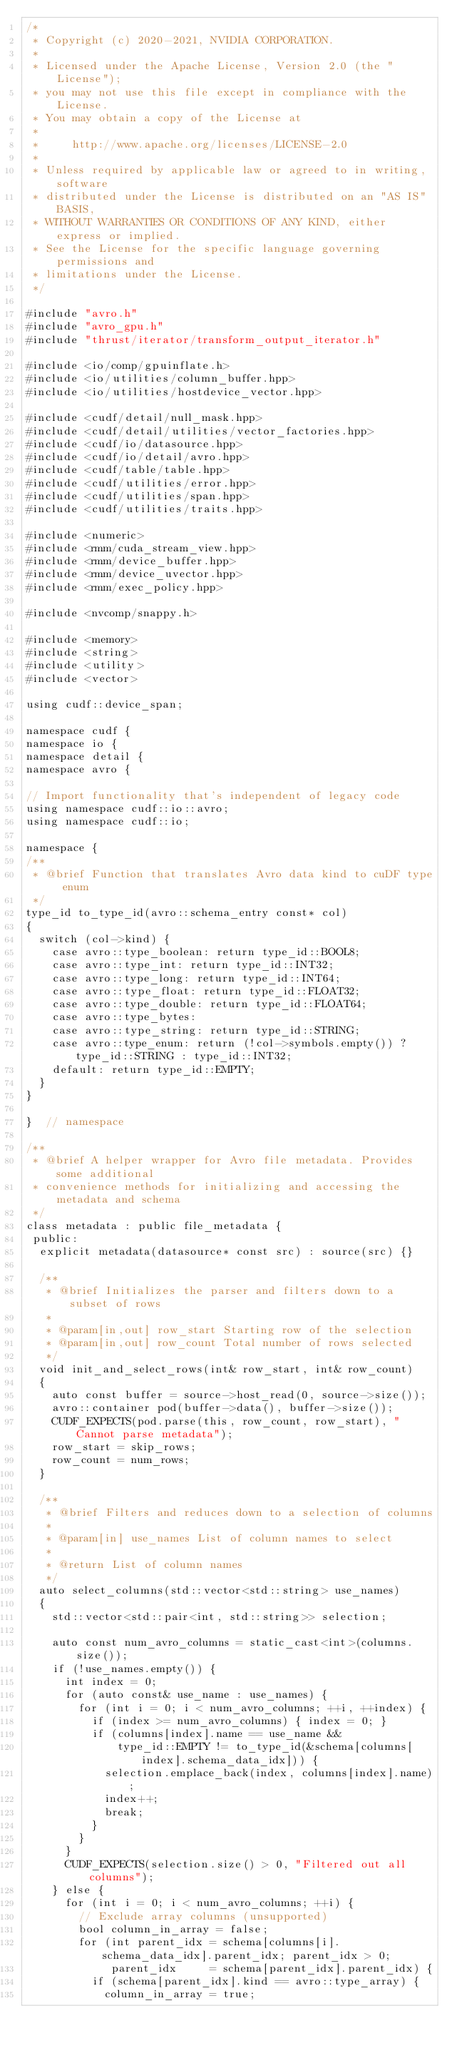Convert code to text. <code><loc_0><loc_0><loc_500><loc_500><_Cuda_>/*
 * Copyright (c) 2020-2021, NVIDIA CORPORATION.
 *
 * Licensed under the Apache License, Version 2.0 (the "License");
 * you may not use this file except in compliance with the License.
 * You may obtain a copy of the License at
 *
 *     http://www.apache.org/licenses/LICENSE-2.0
 *
 * Unless required by applicable law or agreed to in writing, software
 * distributed under the License is distributed on an "AS IS" BASIS,
 * WITHOUT WARRANTIES OR CONDITIONS OF ANY KIND, either express or implied.
 * See the License for the specific language governing permissions and
 * limitations under the License.
 */

#include "avro.h"
#include "avro_gpu.h"
#include "thrust/iterator/transform_output_iterator.h"

#include <io/comp/gpuinflate.h>
#include <io/utilities/column_buffer.hpp>
#include <io/utilities/hostdevice_vector.hpp>

#include <cudf/detail/null_mask.hpp>
#include <cudf/detail/utilities/vector_factories.hpp>
#include <cudf/io/datasource.hpp>
#include <cudf/io/detail/avro.hpp>
#include <cudf/table/table.hpp>
#include <cudf/utilities/error.hpp>
#include <cudf/utilities/span.hpp>
#include <cudf/utilities/traits.hpp>

#include <numeric>
#include <rmm/cuda_stream_view.hpp>
#include <rmm/device_buffer.hpp>
#include <rmm/device_uvector.hpp>
#include <rmm/exec_policy.hpp>

#include <nvcomp/snappy.h>

#include <memory>
#include <string>
#include <utility>
#include <vector>

using cudf::device_span;

namespace cudf {
namespace io {
namespace detail {
namespace avro {

// Import functionality that's independent of legacy code
using namespace cudf::io::avro;
using namespace cudf::io;

namespace {
/**
 * @brief Function that translates Avro data kind to cuDF type enum
 */
type_id to_type_id(avro::schema_entry const* col)
{
  switch (col->kind) {
    case avro::type_boolean: return type_id::BOOL8;
    case avro::type_int: return type_id::INT32;
    case avro::type_long: return type_id::INT64;
    case avro::type_float: return type_id::FLOAT32;
    case avro::type_double: return type_id::FLOAT64;
    case avro::type_bytes:
    case avro::type_string: return type_id::STRING;
    case avro::type_enum: return (!col->symbols.empty()) ? type_id::STRING : type_id::INT32;
    default: return type_id::EMPTY;
  }
}

}  // namespace

/**
 * @brief A helper wrapper for Avro file metadata. Provides some additional
 * convenience methods for initializing and accessing the metadata and schema
 */
class metadata : public file_metadata {
 public:
  explicit metadata(datasource* const src) : source(src) {}

  /**
   * @brief Initializes the parser and filters down to a subset of rows
   *
   * @param[in,out] row_start Starting row of the selection
   * @param[in,out] row_count Total number of rows selected
   */
  void init_and_select_rows(int& row_start, int& row_count)
  {
    auto const buffer = source->host_read(0, source->size());
    avro::container pod(buffer->data(), buffer->size());
    CUDF_EXPECTS(pod.parse(this, row_count, row_start), "Cannot parse metadata");
    row_start = skip_rows;
    row_count = num_rows;
  }

  /**
   * @brief Filters and reduces down to a selection of columns
   *
   * @param[in] use_names List of column names to select
   *
   * @return List of column names
   */
  auto select_columns(std::vector<std::string> use_names)
  {
    std::vector<std::pair<int, std::string>> selection;

    auto const num_avro_columns = static_cast<int>(columns.size());
    if (!use_names.empty()) {
      int index = 0;
      for (auto const& use_name : use_names) {
        for (int i = 0; i < num_avro_columns; ++i, ++index) {
          if (index >= num_avro_columns) { index = 0; }
          if (columns[index].name == use_name &&
              type_id::EMPTY != to_type_id(&schema[columns[index].schema_data_idx])) {
            selection.emplace_back(index, columns[index].name);
            index++;
            break;
          }
        }
      }
      CUDF_EXPECTS(selection.size() > 0, "Filtered out all columns");
    } else {
      for (int i = 0; i < num_avro_columns; ++i) {
        // Exclude array columns (unsupported)
        bool column_in_array = false;
        for (int parent_idx = schema[columns[i].schema_data_idx].parent_idx; parent_idx > 0;
             parent_idx     = schema[parent_idx].parent_idx) {
          if (schema[parent_idx].kind == avro::type_array) {
            column_in_array = true;</code> 